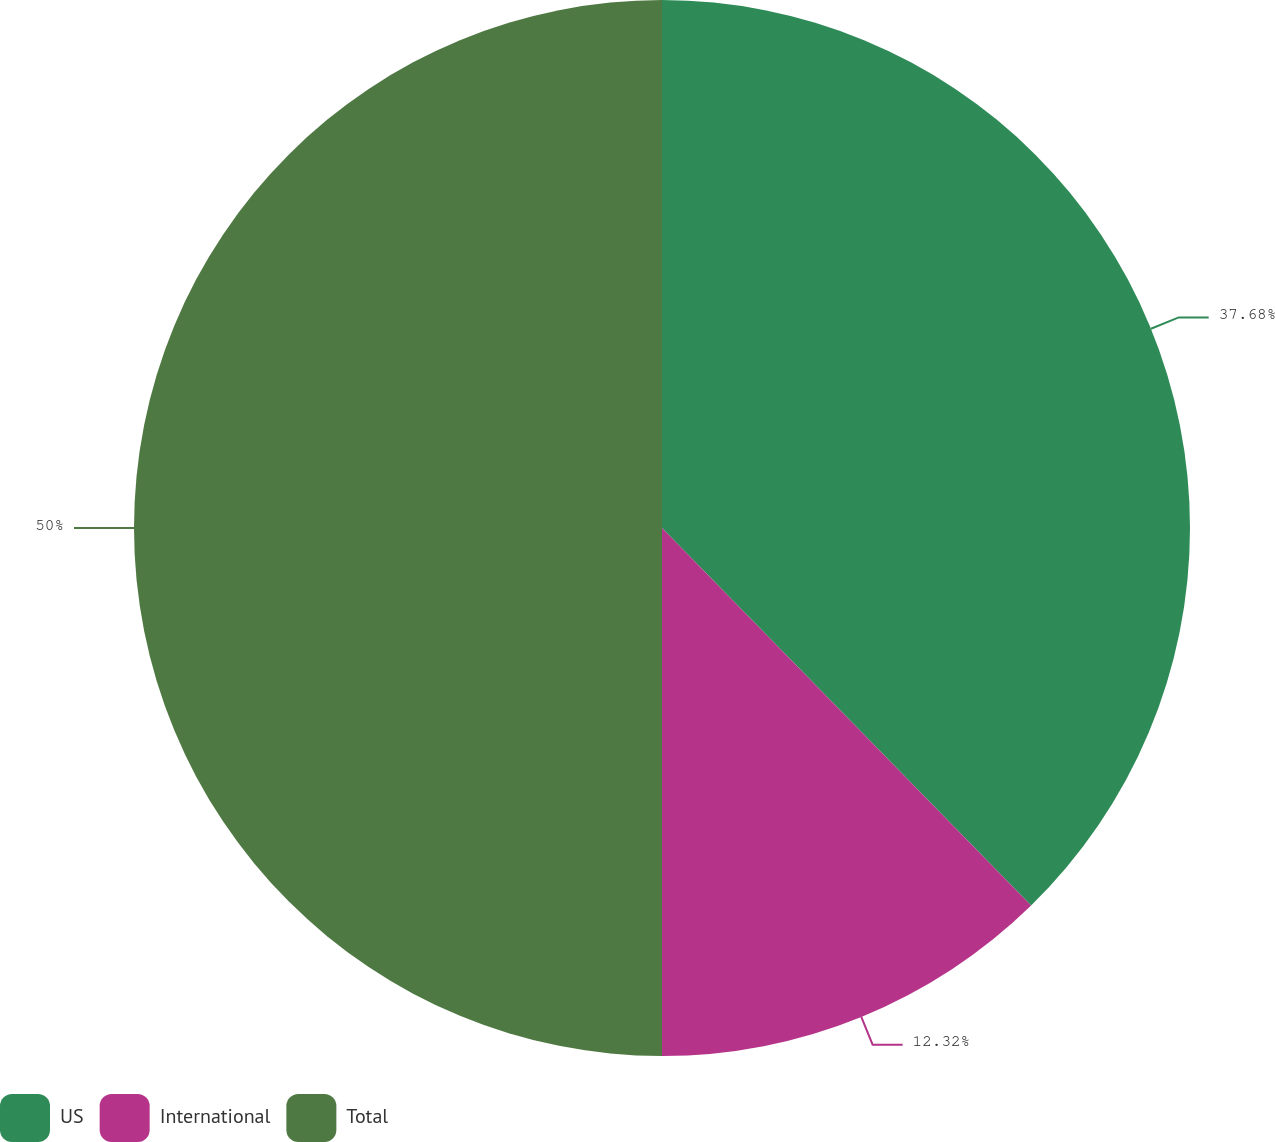<chart> <loc_0><loc_0><loc_500><loc_500><pie_chart><fcel>US<fcel>International<fcel>Total<nl><fcel>37.68%<fcel>12.32%<fcel>50.0%<nl></chart> 